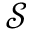Convert formula to latex. <formula><loc_0><loc_0><loc_500><loc_500>\mathcal { S }</formula> 